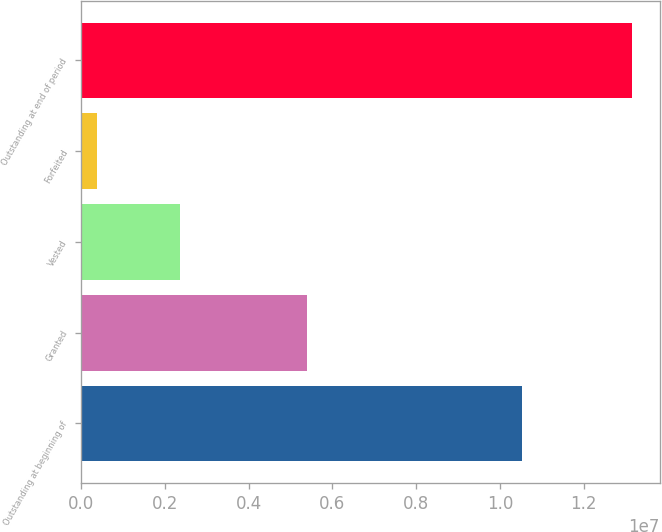<chart> <loc_0><loc_0><loc_500><loc_500><bar_chart><fcel>Outstanding at beginning of<fcel>Granted<fcel>Vested<fcel>Forfeited<fcel>Outstanding at end of period<nl><fcel>1.05183e+07<fcel>5.38948e+06<fcel>2.37119e+06<fcel>382022<fcel>1.31546e+07<nl></chart> 